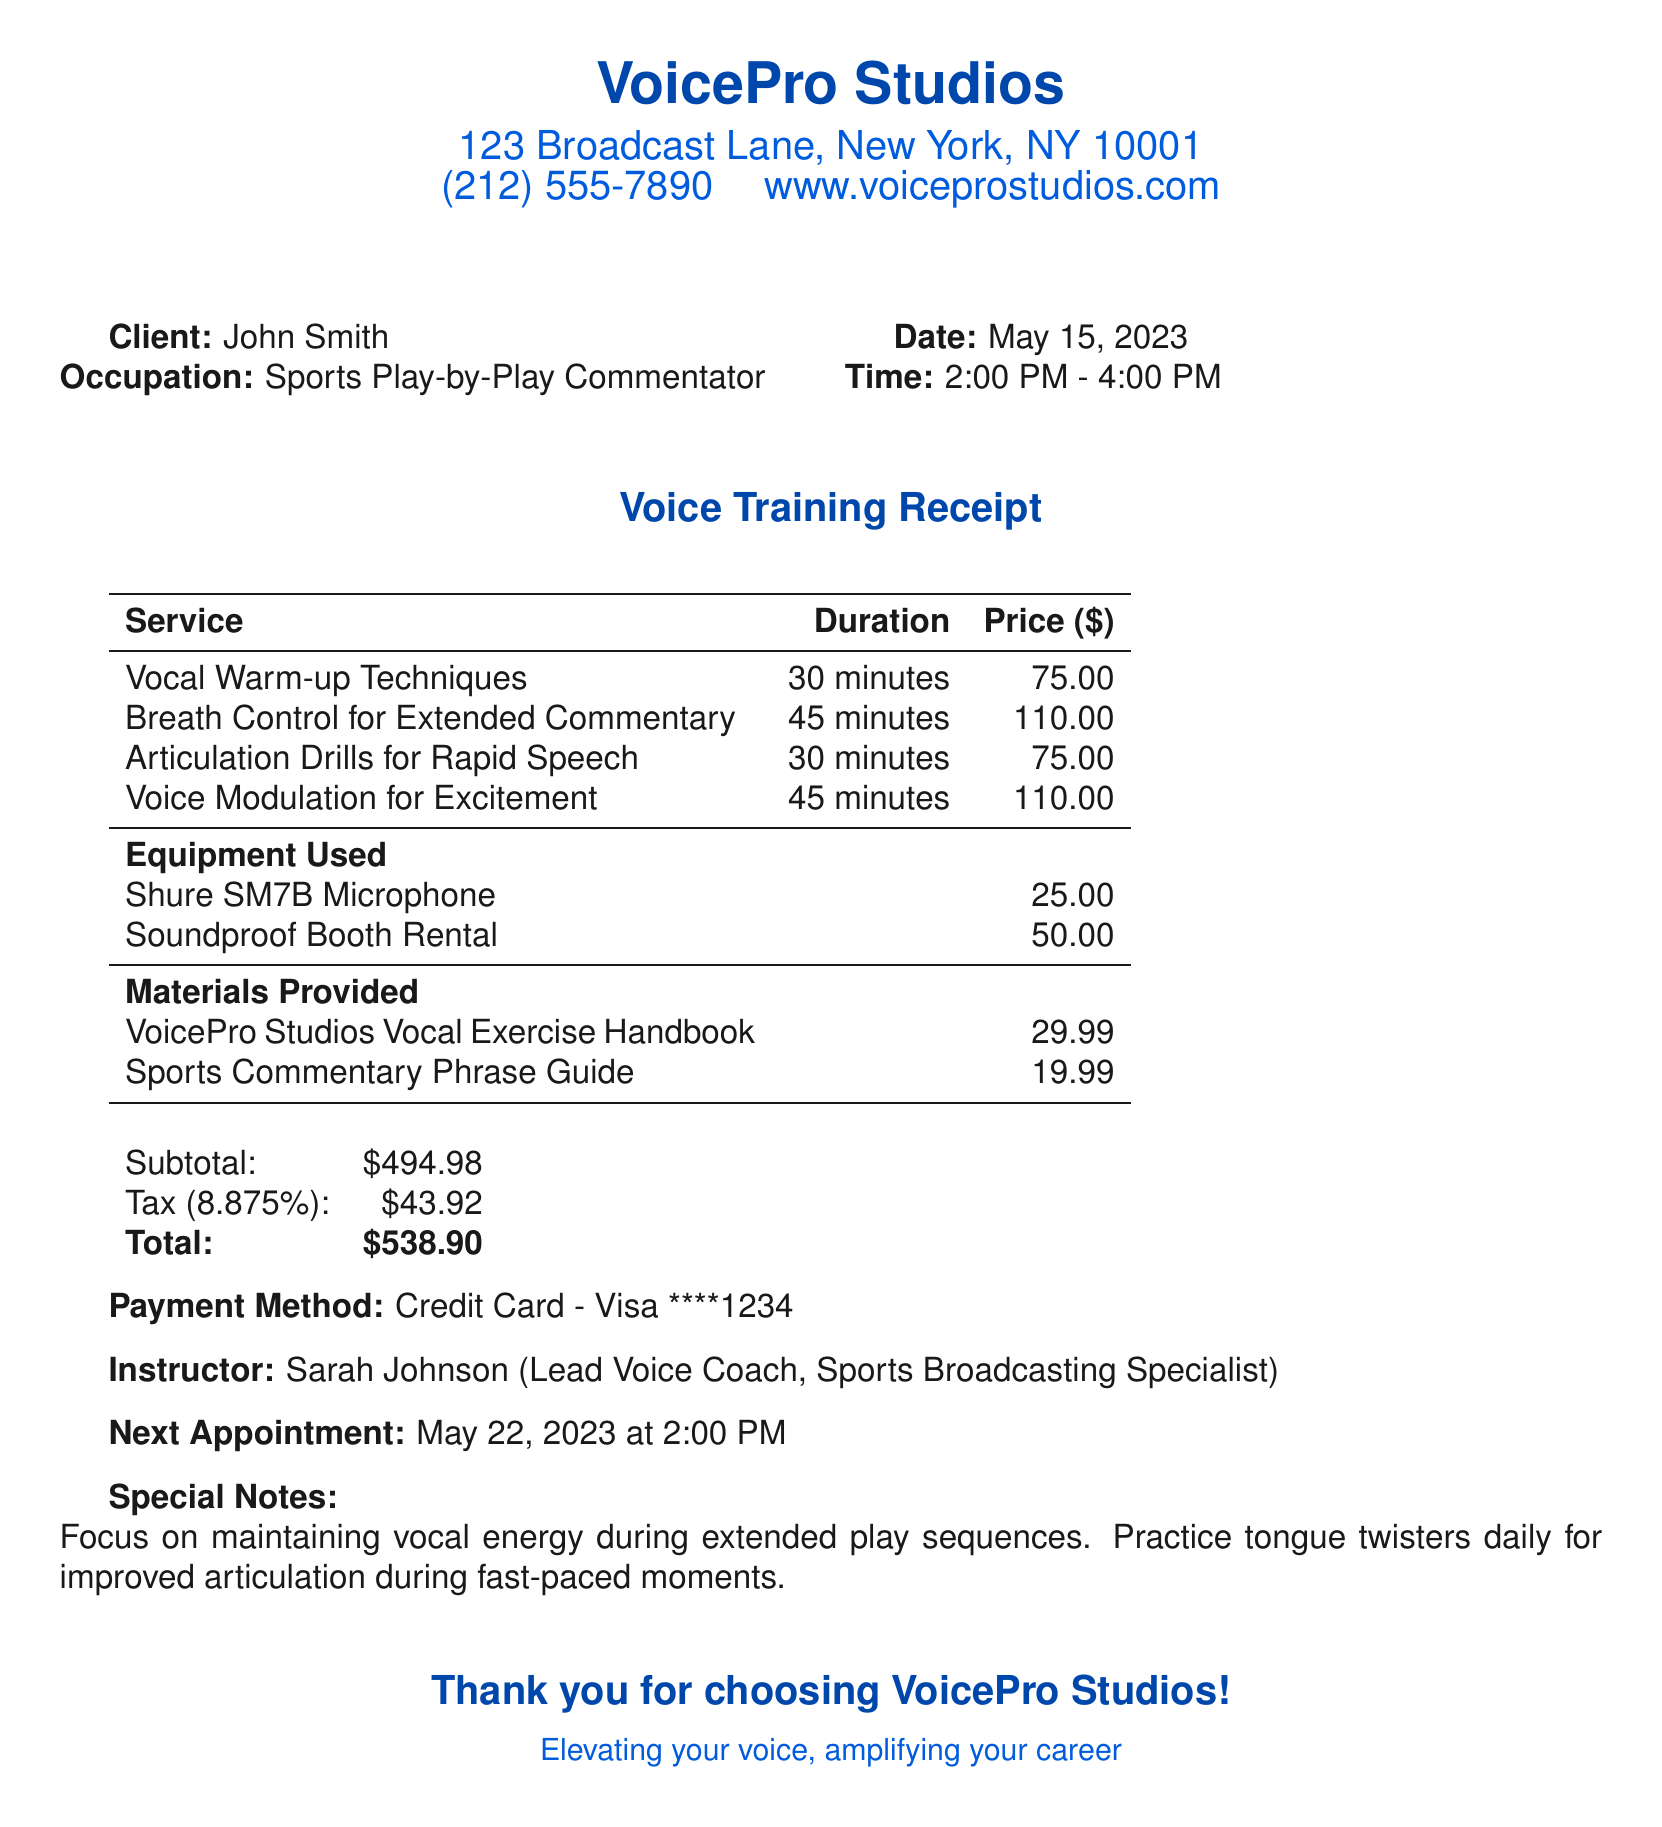What is the business name? The business name is clearly indicated at the top of the document.
Answer: VoicePro Studios Who is the instructor? The instructor's name and title are provided in the document.
Answer: Sarah Johnson What is the total amount due? The total amount is summarized at the bottom of the receipt.
Answer: $538.90 What time does the next appointment occur? The next appointment time is specified in the notes section of the document.
Answer: 2:00 PM What service costs $110.00? The services listed include pricing details, and multiple entries mention this price.
Answer: Breath Control for Extended Commentary What materials were provided? Materials provided are listed with their respective prices in the document.
Answer: VoicePro Studios Vocal Exercise Handbook, Sports Commentary Phrase Guide What is the duration of the Vocal Warm-up Techniques session? The duration for each service is listed alongside them in the documentation.
Answer: 30 minutes What equipment was used during the session? Equipment used is specified in a separate section of the receipt.
Answer: Shure SM7B Microphone, Soundproof Booth Rental What is the tax rate applied? The tax rate is stated clearly in the financial summary section of the document.
Answer: 8.875% 